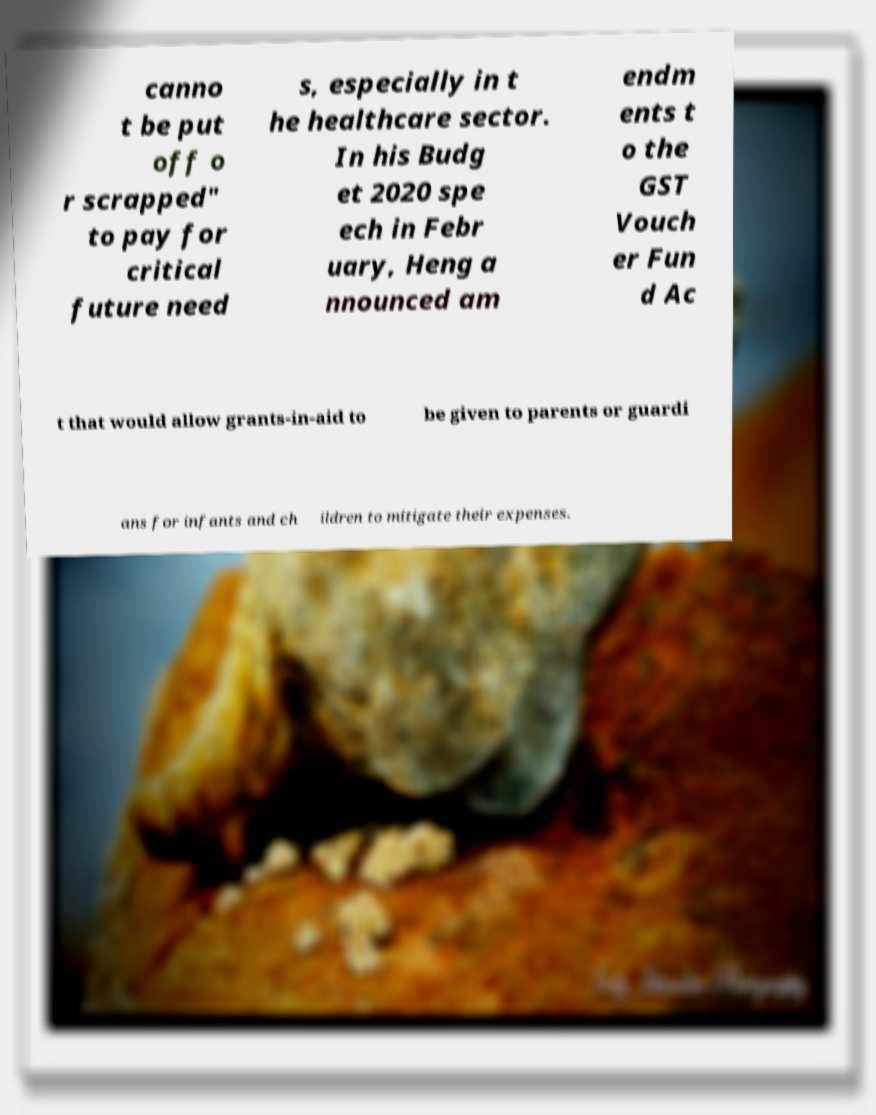Can you read and provide the text displayed in the image?This photo seems to have some interesting text. Can you extract and type it out for me? canno t be put off o r scrapped" to pay for critical future need s, especially in t he healthcare sector. In his Budg et 2020 spe ech in Febr uary, Heng a nnounced am endm ents t o the GST Vouch er Fun d Ac t that would allow grants-in-aid to be given to parents or guardi ans for infants and ch ildren to mitigate their expenses. 